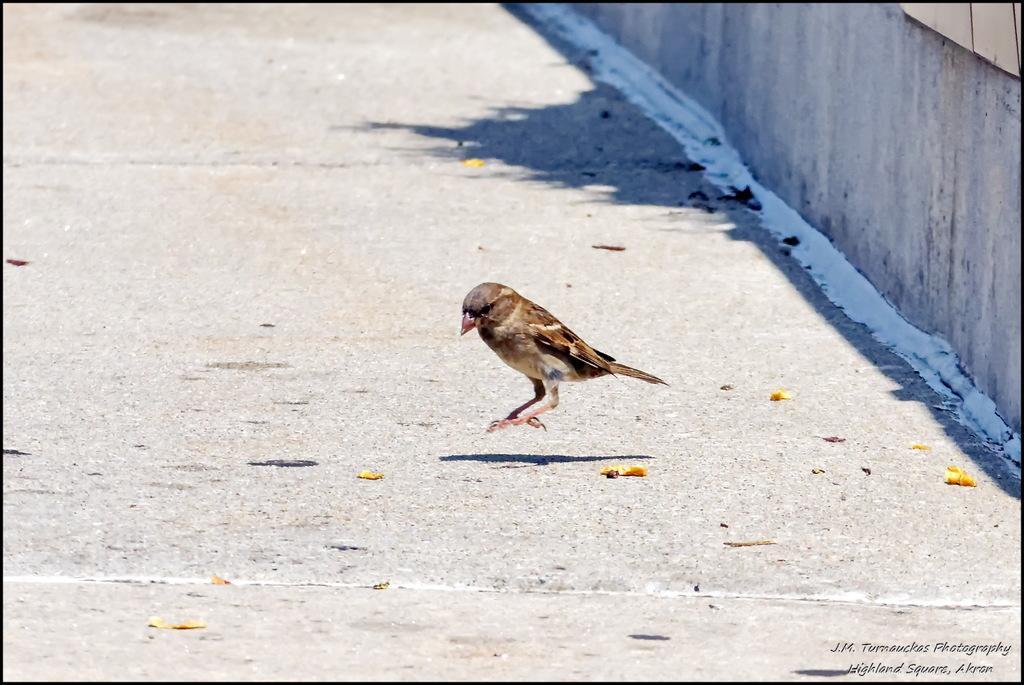How would you summarize this image in a sentence or two? In this image we can see one bird on the road, one wall, one object on the wall, some text on this image and some flower petals on the road. 